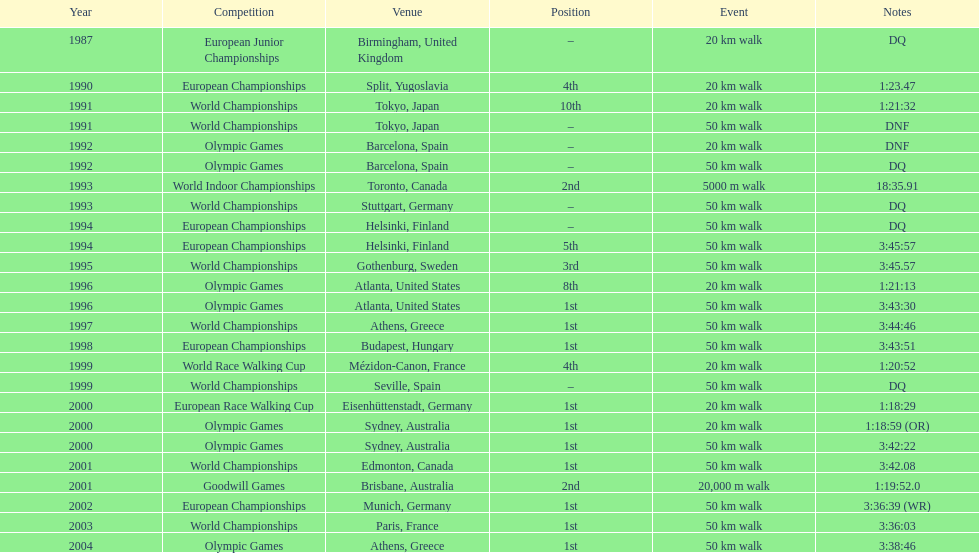How many occurrences was the premier position mentioned as the rank? 10. 